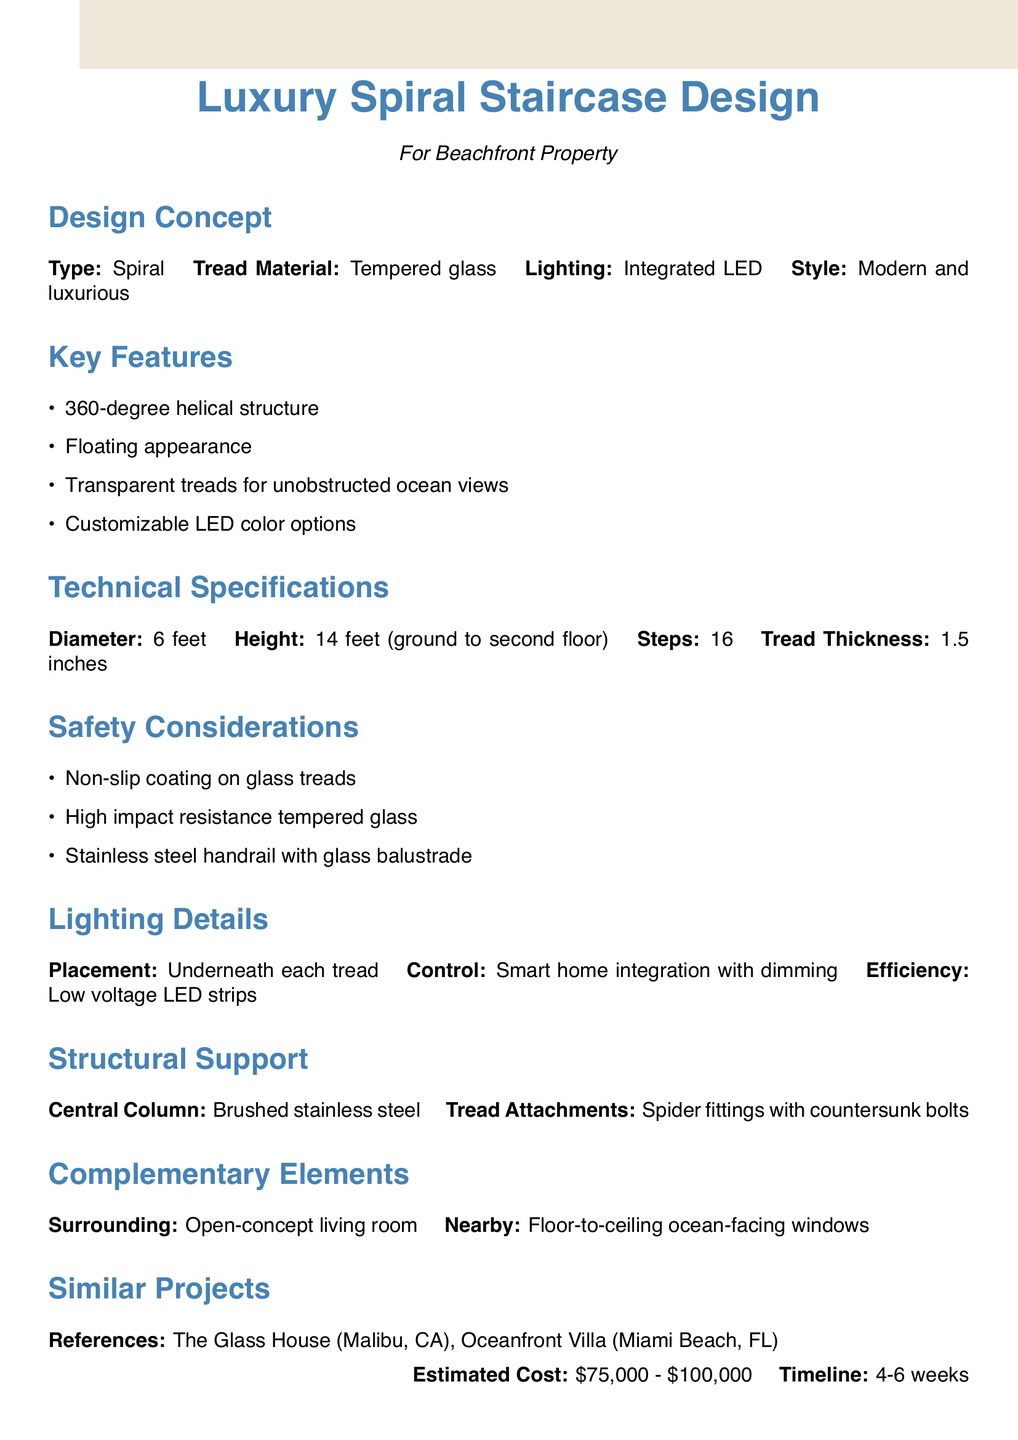What is the type of staircase? The document specifies that the type of staircase is a spiral.
Answer: Spiral What is the tread material used? The document states that the tread material is tempered glass.
Answer: Tempered glass How tall is the staircase? The height of the staircase from the ground floor to the second floor is provided as 14 feet.
Answer: 14 feet What is the estimated cost range for the staircase? According to the document, the estimated cost for the staircase is between $75,000 and $100,000.
Answer: $75,000 - $100,000 What feature allows for unobstructed views? The document mentions that transparent treads provide unobstructed ocean views.
Answer: Transparent treads What kind of lighting is integrated? The document specifies that integrated LED lighting is used.
Answer: Integrated LED How many steps does the staircase have? The number of steps in the staircase is mentioned as 16 in the document.
Answer: 16 What safety feature is noted for the glass treads? The document indicates that there is a non-slip coating on the glass treads as a safety feature.
Answer: Non-slip coating What material is the central column made of? The document states that the central column is made of brushed stainless steel.
Answer: Brushed stainless steel What is the timeline for fabrication and installation? The timeline for custom fabrication and installation is noted as 4-6 weeks in the document.
Answer: 4-6 weeks 